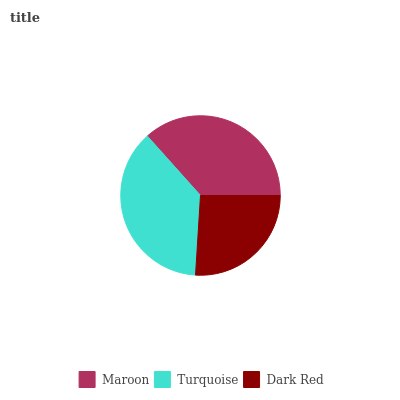Is Dark Red the minimum?
Answer yes or no. Yes. Is Turquoise the maximum?
Answer yes or no. Yes. Is Turquoise the minimum?
Answer yes or no. No. Is Dark Red the maximum?
Answer yes or no. No. Is Turquoise greater than Dark Red?
Answer yes or no. Yes. Is Dark Red less than Turquoise?
Answer yes or no. Yes. Is Dark Red greater than Turquoise?
Answer yes or no. No. Is Turquoise less than Dark Red?
Answer yes or no. No. Is Maroon the high median?
Answer yes or no. Yes. Is Maroon the low median?
Answer yes or no. Yes. Is Turquoise the high median?
Answer yes or no. No. Is Dark Red the low median?
Answer yes or no. No. 